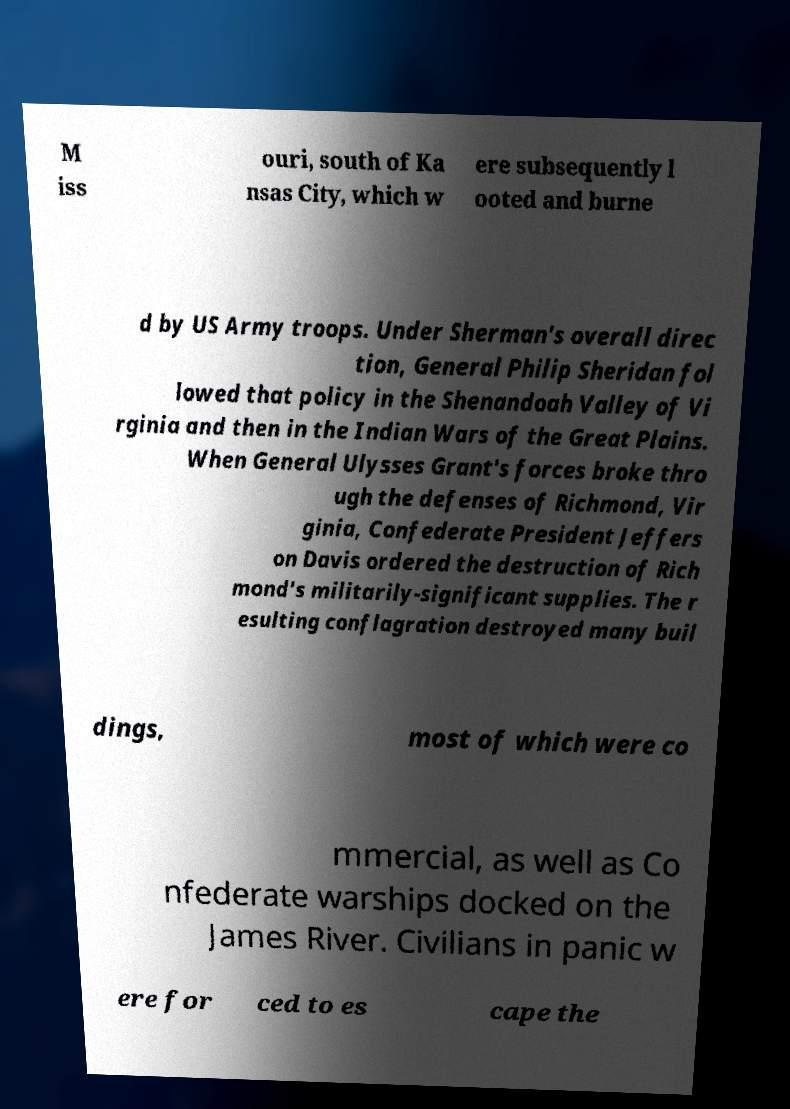Please read and relay the text visible in this image. What does it say? M iss ouri, south of Ka nsas City, which w ere subsequently l ooted and burne d by US Army troops. Under Sherman's overall direc tion, General Philip Sheridan fol lowed that policy in the Shenandoah Valley of Vi rginia and then in the Indian Wars of the Great Plains. When General Ulysses Grant's forces broke thro ugh the defenses of Richmond, Vir ginia, Confederate President Jeffers on Davis ordered the destruction of Rich mond's militarily-significant supplies. The r esulting conflagration destroyed many buil dings, most of which were co mmercial, as well as Co nfederate warships docked on the James River. Civilians in panic w ere for ced to es cape the 